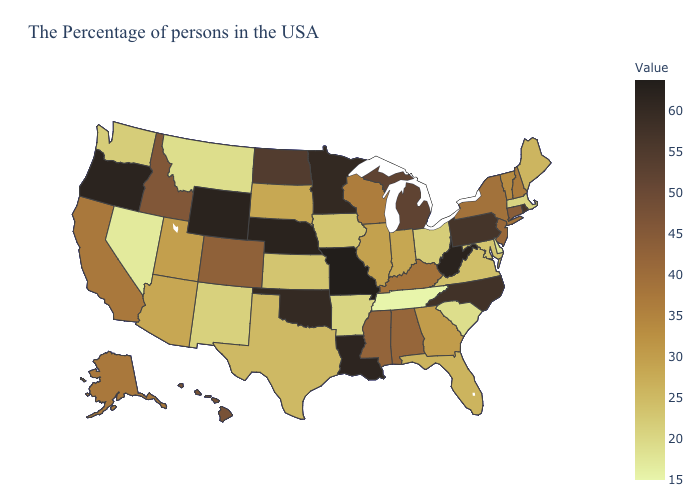Does Wyoming have the highest value in the West?
Answer briefly. Yes. Does Rhode Island have the highest value in the Northeast?
Quick response, please. Yes. Does North Carolina have a higher value than Georgia?
Be succinct. Yes. Does the map have missing data?
Be succinct. No. 